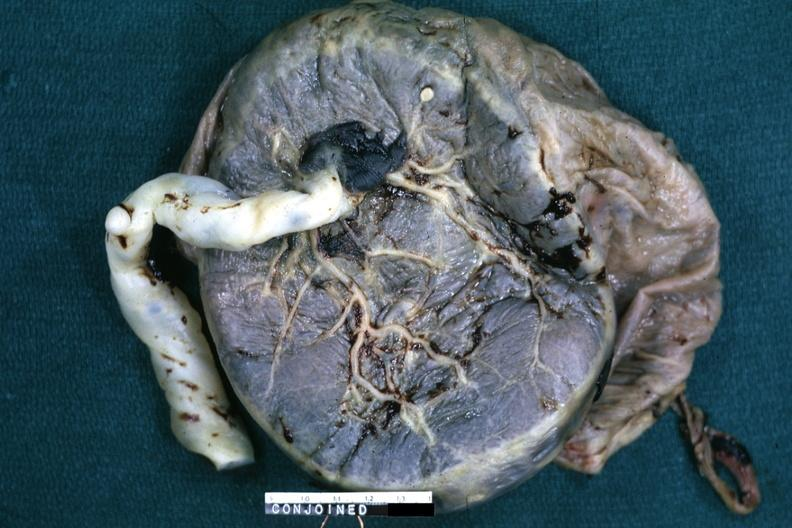where does this belong to?
Answer the question using a single word or phrase. Female reproductive system 